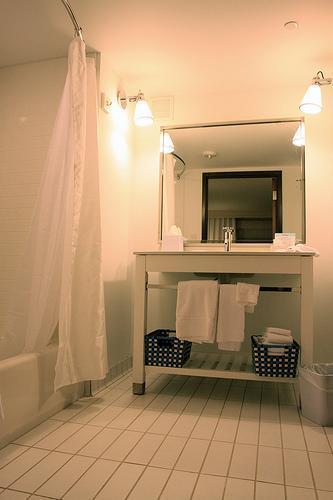How many light are there to the right of the mirror?
Give a very brief answer. 1. 